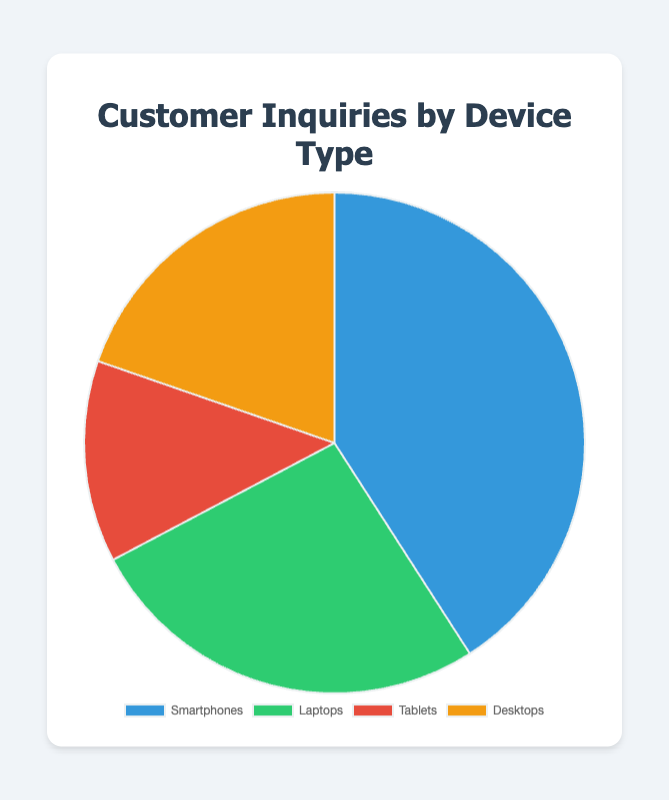Which device type has the highest number of customer inquiries? The pie chart shows different sections for Smartphones, Laptops, Tablets, and Desktops with their respective numbers. Smartphones have the largest section which indicates the highest number of inquiries.
Answer: Smartphones What percentage of the customer inquiries are from Tablets? The tooltip callback function in the chart script calculates the percentage. For tablets, the number of inquiries is 430, and the total inquiries sum is 1350 + 870 + 430 + 650 = 3300. The percentage is (430 / 3300) * 100, approximately 13%.
Answer: 13% How many more inquiries are there for Smartphones than for Laptops? To find the difference, subtract the number of inquiries for Laptops from the number for Smartphones. 1350 (Smartphones) - 870 (Laptops) = 480.
Answer: 480 Which two device types have the lowest number of customer inquiries when summed together? Add up the inquiries for each pair of device types: Tablets and Desktops (430+650 = 1080), Tablets and Laptops (430+870 = 1300), Tablets and Smartphones (430+1350 = 1780), Desktops and Laptops (650+870 = 1520), Desktops and Smartphones (650+1350 = 2000), Laptops and Smartphones (870+1350 = 2220). The lowest sum is from Tablets and Desktops, 1080.
Answer: Tablets and Desktops What is the total number of customer inquiries for all device types combined? Add all the inquiries: 1350 (Smartphones) + 870 (Laptops) + 430 (Tablets) + 650 (Desktops) = 3300.
Answer: 3300 If the number of inquiries for Desktops doubles, will it surpass the number for Smartphones? Doubling the Desktop inquiries: 650 * 2 = 1300. Since 1300 is less than the 1350 inquiries for Smartphones, doubling won’t surpass.
Answer: No What is the percentage difference in customer inquiries between Laptops and Desktops? First, find the difference in inquiries: 870 (Laptops) - 650 (Desktops) = 220. Then, calculate the percentage relative to the total inquiries: (220 / 3300) * 100 ≈ 6.67%.
Answer: 6.67% What two device types combined account for more than 50% of the total inquiries? Find the sum for each pair and calculate their percentage of the total. For Smartphones (1350) and Laptops (870): 1350 + 870 = 2220, which is more than 50% of 3300 (2220/3300)*100 ≈ 67%.
Answer: Smartphones and Laptops 